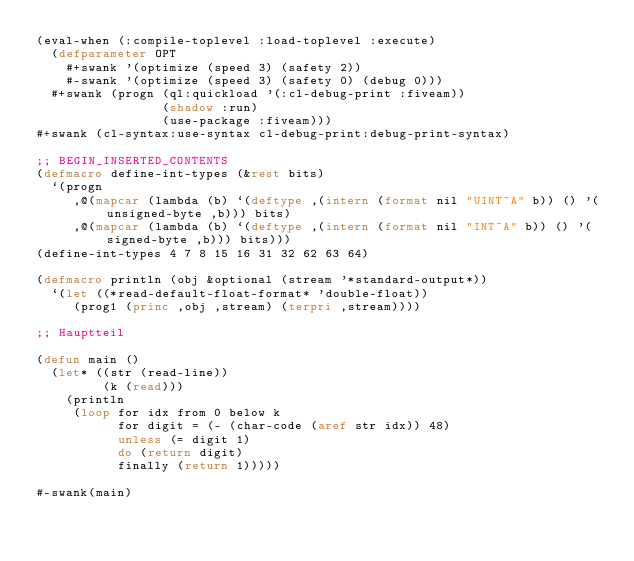Convert code to text. <code><loc_0><loc_0><loc_500><loc_500><_Lisp_>(eval-when (:compile-toplevel :load-toplevel :execute)
  (defparameter OPT
    #+swank '(optimize (speed 3) (safety 2))
    #-swank '(optimize (speed 3) (safety 0) (debug 0)))
  #+swank (progn (ql:quickload '(:cl-debug-print :fiveam))
                 (shadow :run)
                 (use-package :fiveam)))
#+swank (cl-syntax:use-syntax cl-debug-print:debug-print-syntax)

;; BEGIN_INSERTED_CONTENTS
(defmacro define-int-types (&rest bits)
  `(progn
     ,@(mapcar (lambda (b) `(deftype ,(intern (format nil "UINT~A" b)) () '(unsigned-byte ,b))) bits)
     ,@(mapcar (lambda (b) `(deftype ,(intern (format nil "INT~A" b)) () '(signed-byte ,b))) bits)))
(define-int-types 4 7 8 15 16 31 32 62 63 64)

(defmacro println (obj &optional (stream '*standard-output*))
  `(let ((*read-default-float-format* 'double-float))
     (prog1 (princ ,obj ,stream) (terpri ,stream))))

;; Hauptteil

(defun main ()
  (let* ((str (read-line))
         (k (read)))
    (println
     (loop for idx from 0 below k
           for digit = (- (char-code (aref str idx)) 48)
           unless (= digit 1)
           do (return digit)
           finally (return 1)))))

#-swank(main)

</code> 